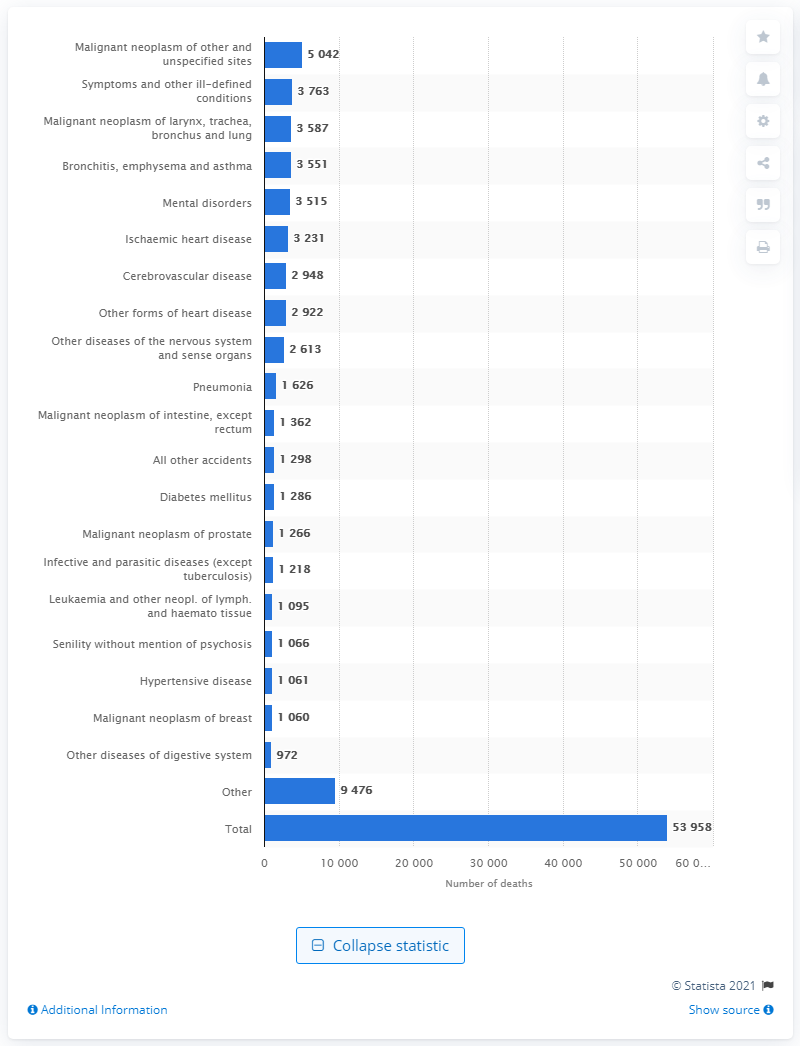Draw attention to some important aspects in this diagram. In 2019, a total of 53,958 people passed away in Denmark. 